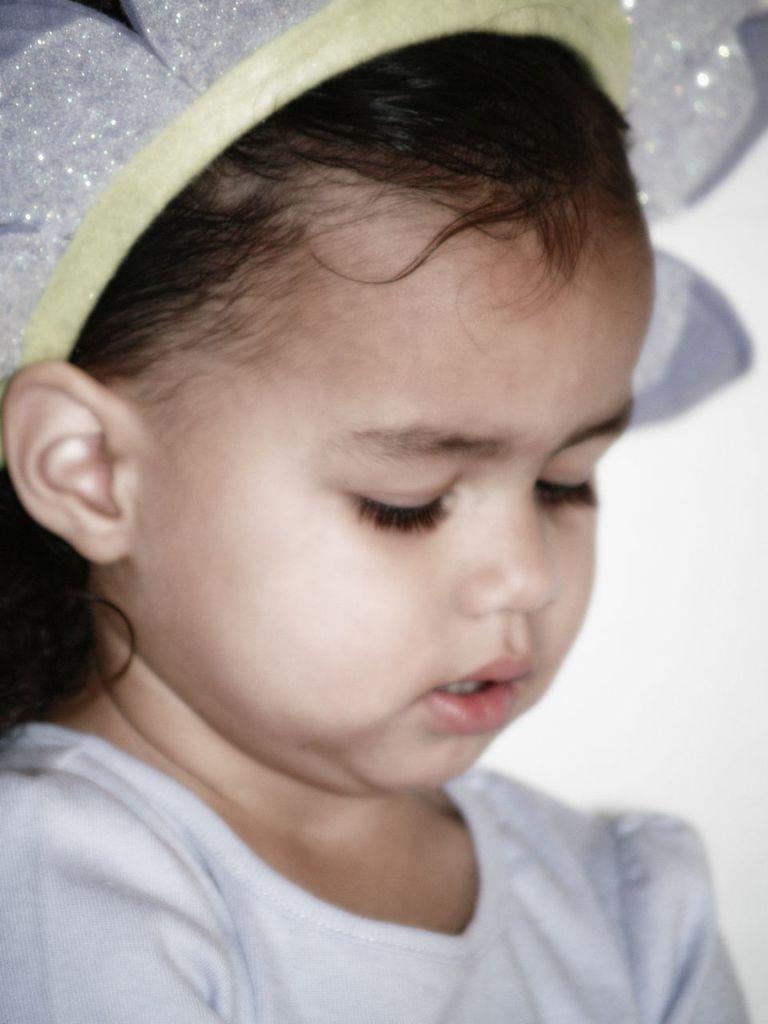Can you describe this image briefly? In the image there is a baby with white top and a white clip over her head. 